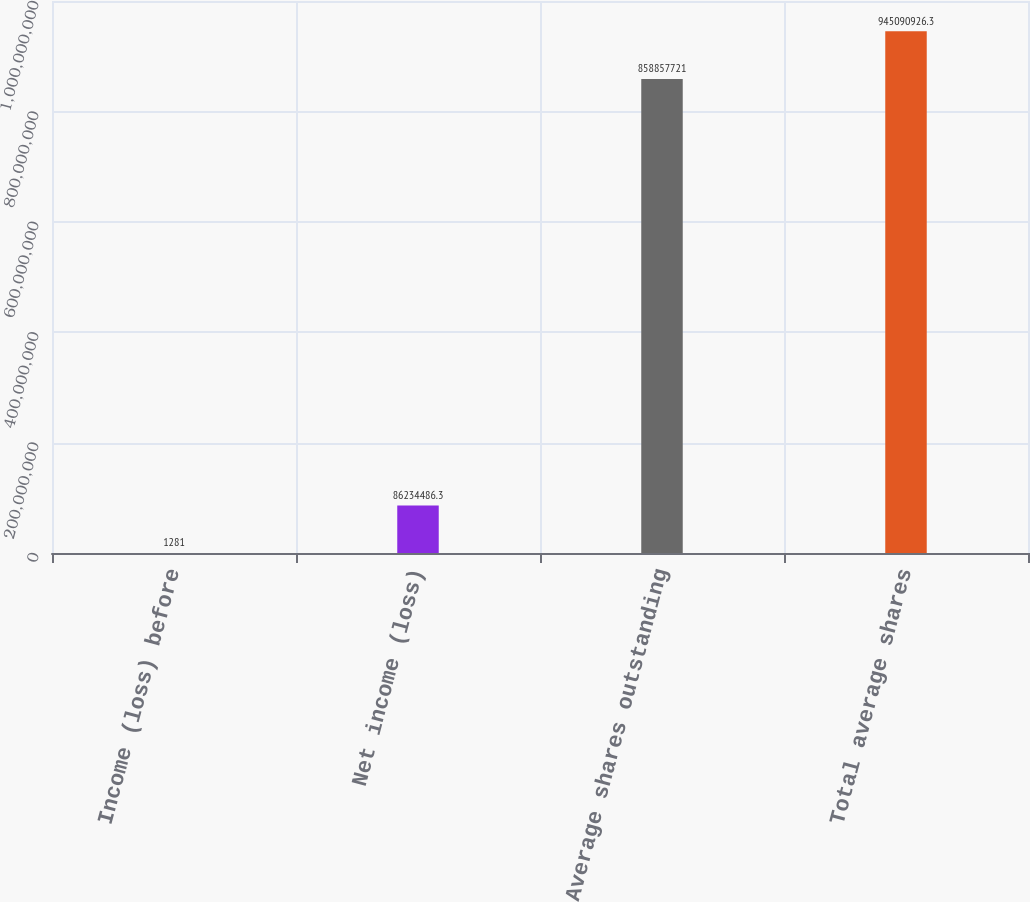Convert chart to OTSL. <chart><loc_0><loc_0><loc_500><loc_500><bar_chart><fcel>Income (loss) before<fcel>Net income (loss)<fcel>Average shares outstanding<fcel>Total average shares<nl><fcel>1281<fcel>8.62345e+07<fcel>8.58858e+08<fcel>9.45091e+08<nl></chart> 